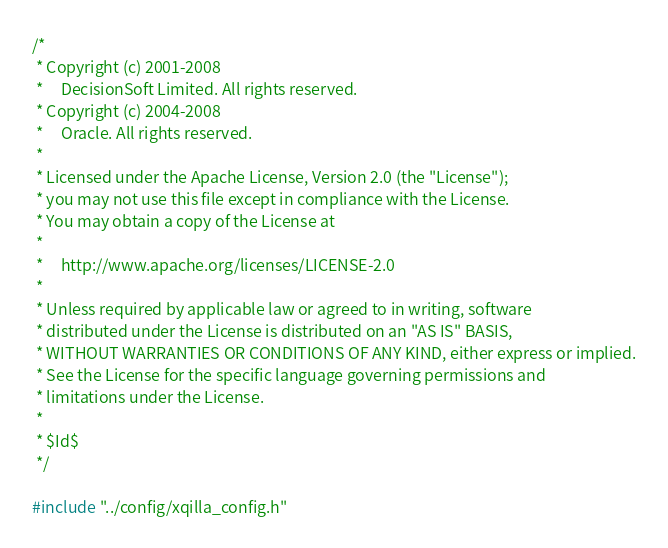<code> <loc_0><loc_0><loc_500><loc_500><_C++_>/*
 * Copyright (c) 2001-2008
 *     DecisionSoft Limited. All rights reserved.
 * Copyright (c) 2004-2008
 *     Oracle. All rights reserved.
 *
 * Licensed under the Apache License, Version 2.0 (the "License");
 * you may not use this file except in compliance with the License.
 * You may obtain a copy of the License at
 *
 *     http://www.apache.org/licenses/LICENSE-2.0
 *
 * Unless required by applicable law or agreed to in writing, software
 * distributed under the License is distributed on an "AS IS" BASIS,
 * WITHOUT WARRANTIES OR CONDITIONS OF ANY KIND, either express or implied.
 * See the License for the specific language governing permissions and
 * limitations under the License.
 *
 * $Id$
 */

#include "../config/xqilla_config.h"
</code> 